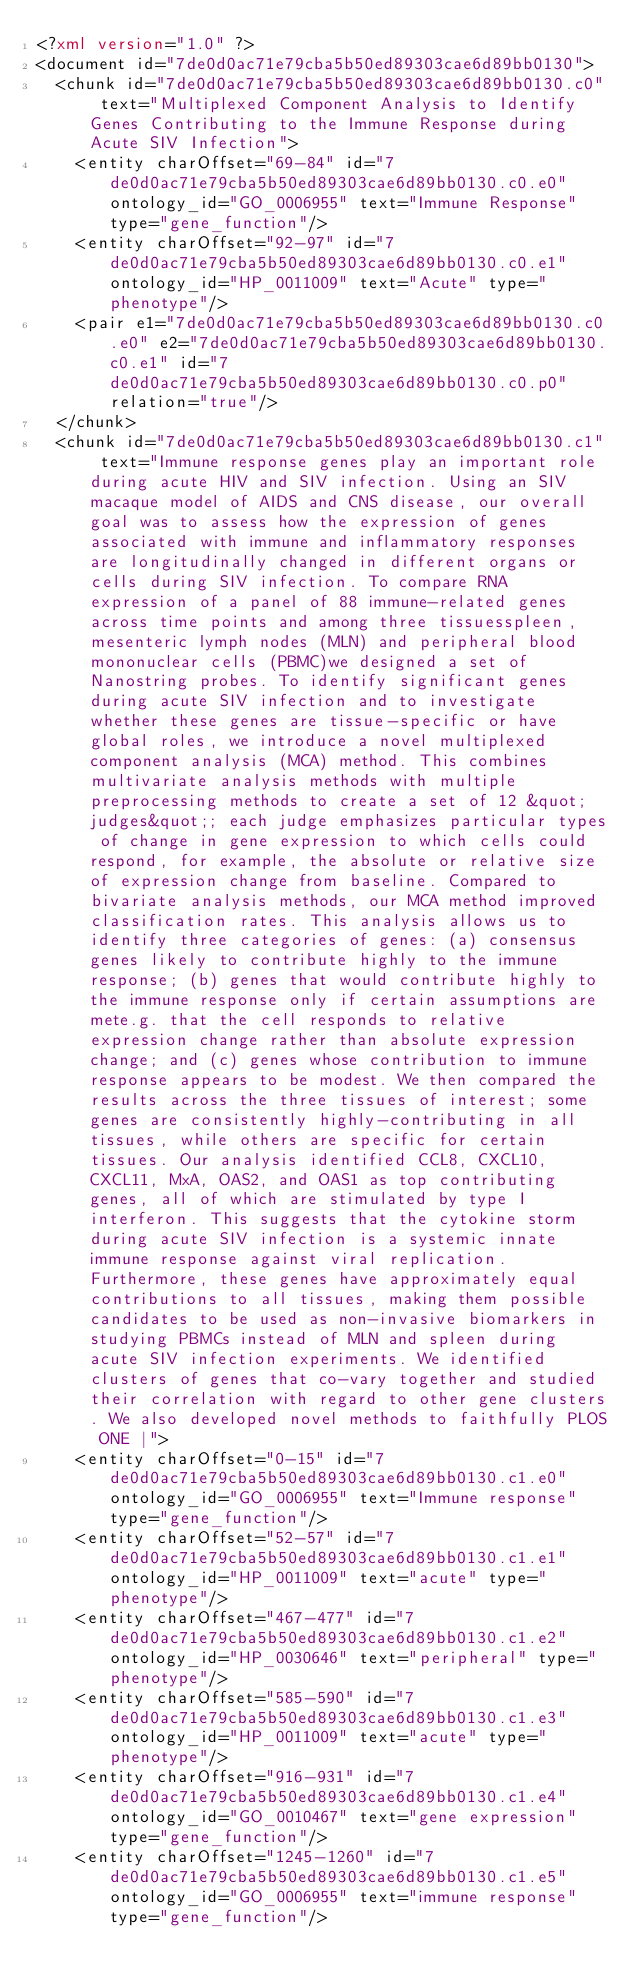Convert code to text. <code><loc_0><loc_0><loc_500><loc_500><_XML_><?xml version="1.0" ?>
<document id="7de0d0ac71e79cba5b50ed89303cae6d89bb0130">
  <chunk id="7de0d0ac71e79cba5b50ed89303cae6d89bb0130.c0" text="Multiplexed Component Analysis to Identify Genes Contributing to the Immune Response during Acute SIV Infection">
    <entity charOffset="69-84" id="7de0d0ac71e79cba5b50ed89303cae6d89bb0130.c0.e0" ontology_id="GO_0006955" text="Immune Response" type="gene_function"/>
    <entity charOffset="92-97" id="7de0d0ac71e79cba5b50ed89303cae6d89bb0130.c0.e1" ontology_id="HP_0011009" text="Acute" type="phenotype"/>
    <pair e1="7de0d0ac71e79cba5b50ed89303cae6d89bb0130.c0.e0" e2="7de0d0ac71e79cba5b50ed89303cae6d89bb0130.c0.e1" id="7de0d0ac71e79cba5b50ed89303cae6d89bb0130.c0.p0" relation="true"/>
  </chunk>
  <chunk id="7de0d0ac71e79cba5b50ed89303cae6d89bb0130.c1" text="Immune response genes play an important role during acute HIV and SIV infection. Using an SIV macaque model of AIDS and CNS disease, our overall goal was to assess how the expression of genes associated with immune and inflammatory responses are longitudinally changed in different organs or cells during SIV infection. To compare RNA expression of a panel of 88 immune-related genes across time points and among three tissuesspleen, mesenteric lymph nodes (MLN) and peripheral blood mononuclear cells (PBMC)we designed a set of Nanostring probes. To identify significant genes during acute SIV infection and to investigate whether these genes are tissue-specific or have global roles, we introduce a novel multiplexed component analysis (MCA) method. This combines multivariate analysis methods with multiple preprocessing methods to create a set of 12 &quot;judges&quot;; each judge emphasizes particular types of change in gene expression to which cells could respond, for example, the absolute or relative size of expression change from baseline. Compared to bivariate analysis methods, our MCA method improved classification rates. This analysis allows us to identify three categories of genes: (a) consensus genes likely to contribute highly to the immune response; (b) genes that would contribute highly to the immune response only if certain assumptions are mete.g. that the cell responds to relative expression change rather than absolute expression change; and (c) genes whose contribution to immune response appears to be modest. We then compared the results across the three tissues of interest; some genes are consistently highly-contributing in all tissues, while others are specific for certain tissues. Our analysis identified CCL8, CXCL10, CXCL11, MxA, OAS2, and OAS1 as top contributing genes, all of which are stimulated by type I interferon. This suggests that the cytokine storm during acute SIV infection is a systemic innate immune response against viral replication. Furthermore, these genes have approximately equal contributions to all tissues, making them possible candidates to be used as non-invasive biomarkers in studying PBMCs instead of MLN and spleen during acute SIV infection experiments. We identified clusters of genes that co-vary together and studied their correlation with regard to other gene clusters. We also developed novel methods to faithfully PLOS ONE |">
    <entity charOffset="0-15" id="7de0d0ac71e79cba5b50ed89303cae6d89bb0130.c1.e0" ontology_id="GO_0006955" text="Immune response" type="gene_function"/>
    <entity charOffset="52-57" id="7de0d0ac71e79cba5b50ed89303cae6d89bb0130.c1.e1" ontology_id="HP_0011009" text="acute" type="phenotype"/>
    <entity charOffset="467-477" id="7de0d0ac71e79cba5b50ed89303cae6d89bb0130.c1.e2" ontology_id="HP_0030646" text="peripheral" type="phenotype"/>
    <entity charOffset="585-590" id="7de0d0ac71e79cba5b50ed89303cae6d89bb0130.c1.e3" ontology_id="HP_0011009" text="acute" type="phenotype"/>
    <entity charOffset="916-931" id="7de0d0ac71e79cba5b50ed89303cae6d89bb0130.c1.e4" ontology_id="GO_0010467" text="gene expression" type="gene_function"/>
    <entity charOffset="1245-1260" id="7de0d0ac71e79cba5b50ed89303cae6d89bb0130.c1.e5" ontology_id="GO_0006955" text="immune response" type="gene_function"/></code> 